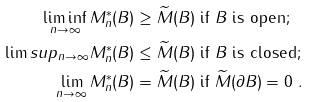<formula> <loc_0><loc_0><loc_500><loc_500>\liminf _ { n \to \infty } M ^ { * } _ { n } ( B ) & \geq \widetilde { M } ( B ) \text { if $B$ is open;} \\ \lim s u p _ { n \to \infty } M ^ { * } _ { n } ( B ) & \leq \widetilde { M } ( B ) \text { if $B$ is closed;} \\ \lim _ { n \to \infty } M ^ { * } _ { n } ( B ) & = \widetilde { M } ( B ) \text { if } \widetilde { M } ( \partial B ) = 0 \ .</formula> 